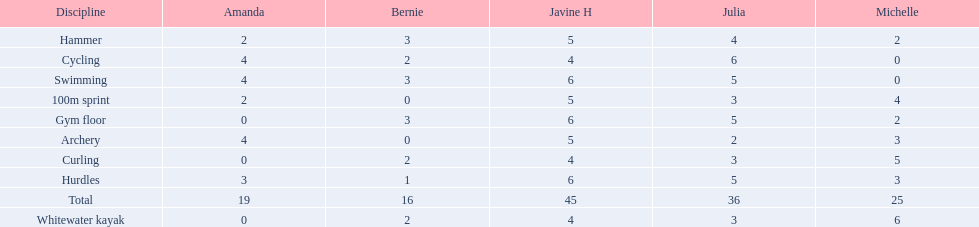What are the number of points bernie scored in hurdles? 1. 